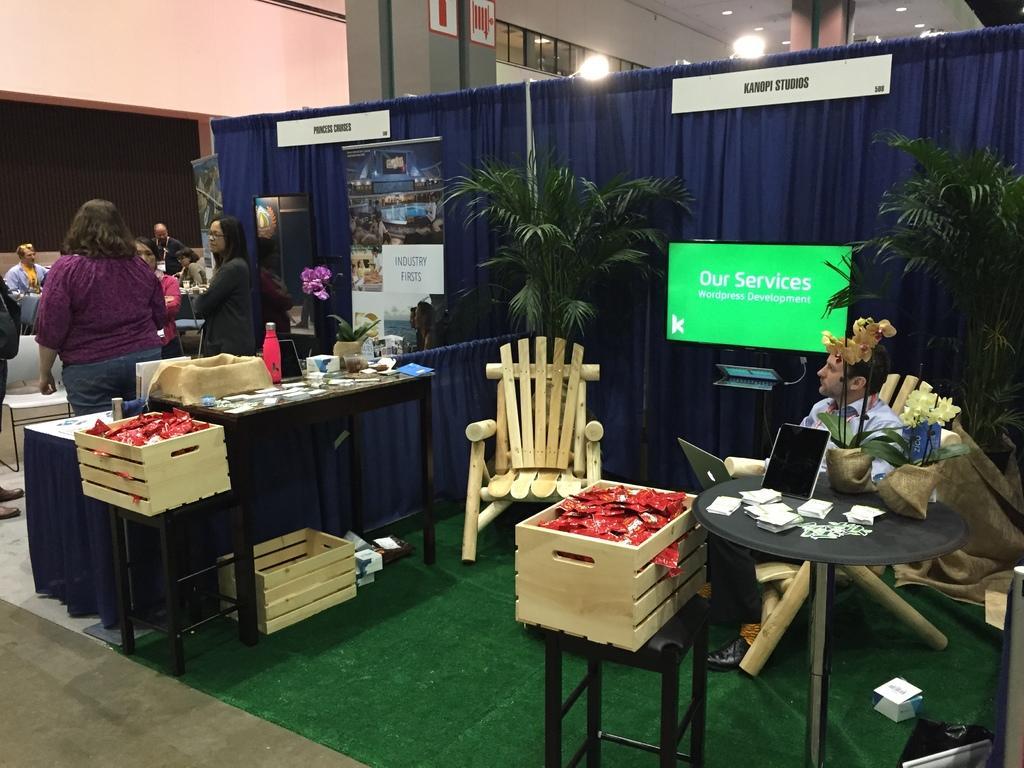Describe this image in one or two sentences. This is the picture of a place where we have two cabin like things and in one cabin there some chairs,table,screen,two plants and the wooden box and in the other cabin there are person standing and some note on the board. 